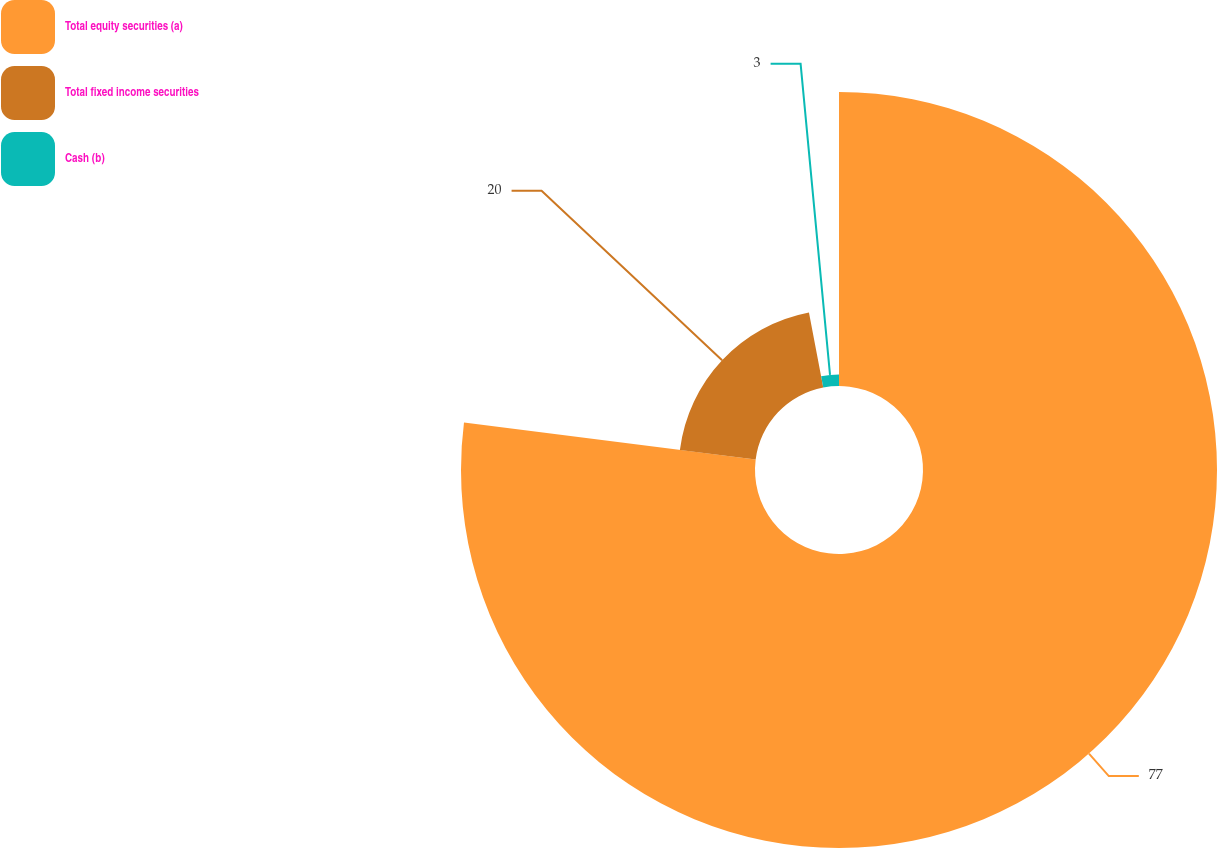<chart> <loc_0><loc_0><loc_500><loc_500><pie_chart><fcel>Total equity securities (a)<fcel>Total fixed income securities<fcel>Cash (b)<nl><fcel>77.0%<fcel>20.0%<fcel>3.0%<nl></chart> 